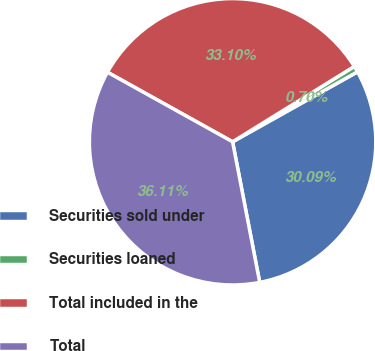Convert chart to OTSL. <chart><loc_0><loc_0><loc_500><loc_500><pie_chart><fcel>Securities sold under<fcel>Securities loaned<fcel>Total included in the<fcel>Total<nl><fcel>30.09%<fcel>0.7%<fcel>33.1%<fcel>36.11%<nl></chart> 